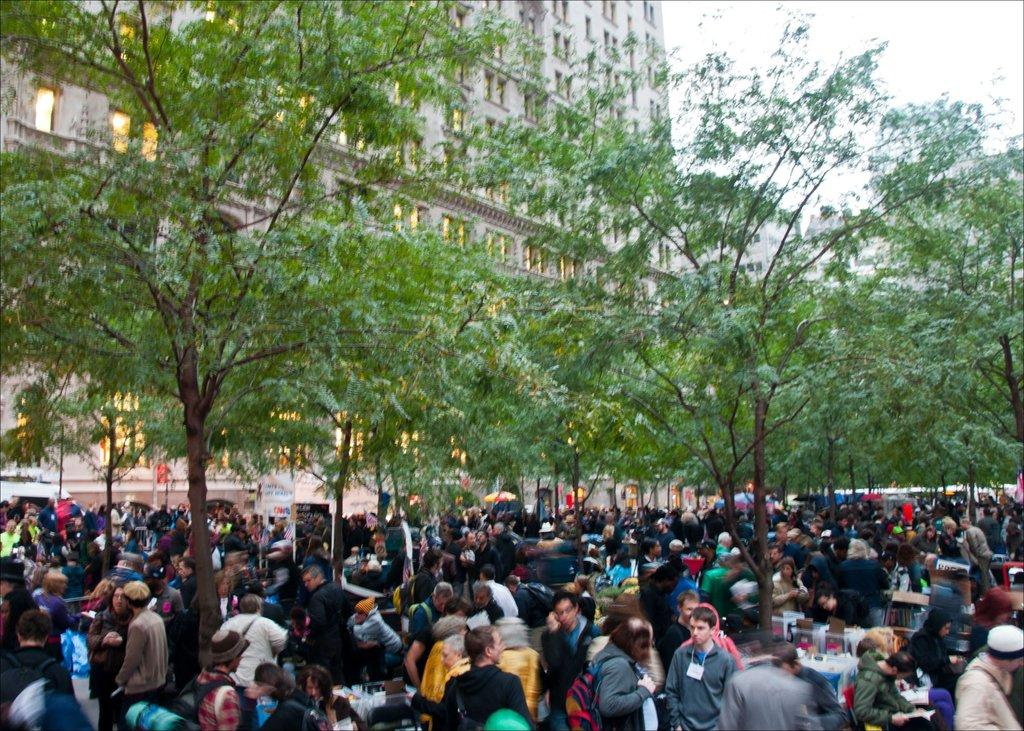What is the main subject of the image? The main subject of the image is a large crowd of people. What can be seen in the middle of the image? Trees are present in the middle of the image. What is located behind the trees in the image? There is a building behind the trees. What part of the sky is visible in the image? The sky is visible at the top right of the image. How many legs can be seen on the cows in the image? There are no cows present in the image, so the number of legs cannot be determined. 